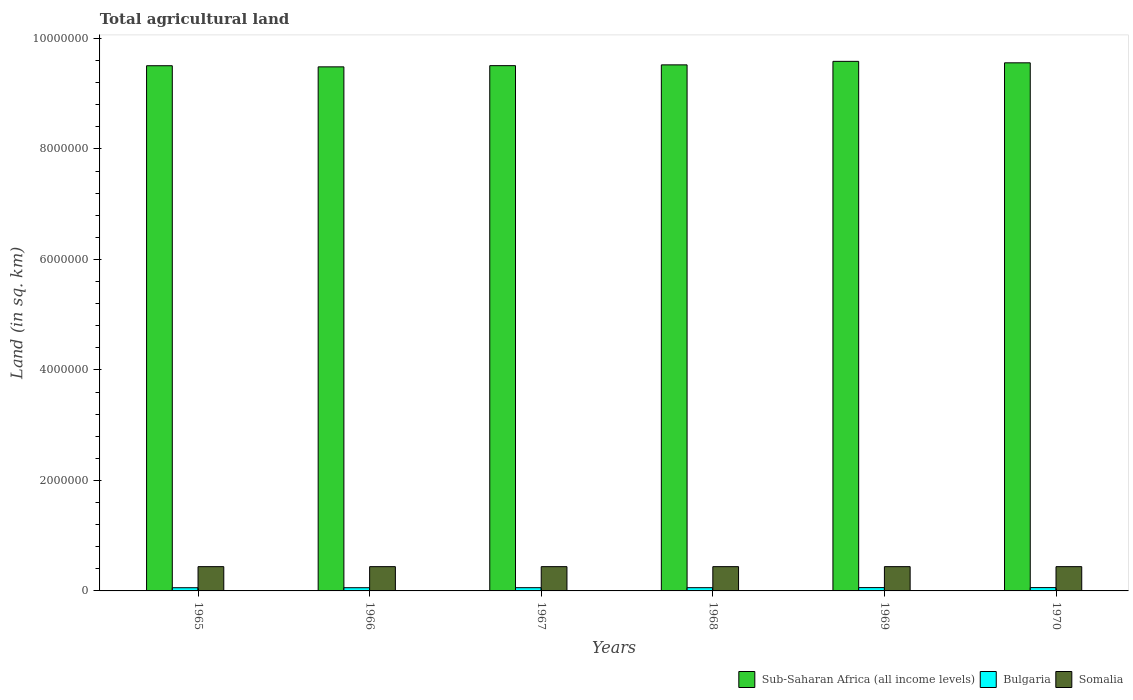How many groups of bars are there?
Give a very brief answer. 6. Are the number of bars per tick equal to the number of legend labels?
Offer a terse response. Yes. How many bars are there on the 3rd tick from the right?
Your answer should be very brief. 3. What is the label of the 5th group of bars from the left?
Offer a very short reply. 1969. In how many cases, is the number of bars for a given year not equal to the number of legend labels?
Provide a short and direct response. 0. What is the total agricultural land in Sub-Saharan Africa (all income levels) in 1970?
Offer a terse response. 9.56e+06. Across all years, what is the maximum total agricultural land in Sub-Saharan Africa (all income levels)?
Your response must be concise. 9.59e+06. Across all years, what is the minimum total agricultural land in Somalia?
Your response must be concise. 4.39e+05. In which year was the total agricultural land in Sub-Saharan Africa (all income levels) maximum?
Your response must be concise. 1969. In which year was the total agricultural land in Somalia minimum?
Your answer should be very brief. 1965. What is the total total agricultural land in Somalia in the graph?
Keep it short and to the point. 2.64e+06. What is the difference between the total agricultural land in Somalia in 1965 and that in 1970?
Keep it short and to the point. -250. What is the difference between the total agricultural land in Sub-Saharan Africa (all income levels) in 1968 and the total agricultural land in Somalia in 1967?
Your response must be concise. 9.08e+06. What is the average total agricultural land in Sub-Saharan Africa (all income levels) per year?
Offer a very short reply. 9.53e+06. In the year 1968, what is the difference between the total agricultural land in Somalia and total agricultural land in Sub-Saharan Africa (all income levels)?
Give a very brief answer. -9.08e+06. In how many years, is the total agricultural land in Bulgaria greater than 7200000 sq.km?
Your answer should be very brief. 0. What is the ratio of the total agricultural land in Bulgaria in 1965 to that in 1968?
Ensure brevity in your answer.  0.99. Is the difference between the total agricultural land in Somalia in 1966 and 1970 greater than the difference between the total agricultural land in Sub-Saharan Africa (all income levels) in 1966 and 1970?
Your response must be concise. Yes. What is the difference between the highest and the lowest total agricultural land in Bulgaria?
Make the answer very short. 2290. In how many years, is the total agricultural land in Bulgaria greater than the average total agricultural land in Bulgaria taken over all years?
Keep it short and to the point. 2. What does the 1st bar from the left in 1969 represents?
Your response must be concise. Sub-Saharan Africa (all income levels). What does the 3rd bar from the right in 1970 represents?
Offer a terse response. Sub-Saharan Africa (all income levels). How many bars are there?
Provide a succinct answer. 18. Are the values on the major ticks of Y-axis written in scientific E-notation?
Make the answer very short. No. Does the graph contain any zero values?
Give a very brief answer. No. Does the graph contain grids?
Provide a short and direct response. No. How many legend labels are there?
Offer a very short reply. 3. What is the title of the graph?
Provide a short and direct response. Total agricultural land. What is the label or title of the X-axis?
Offer a very short reply. Years. What is the label or title of the Y-axis?
Provide a succinct answer. Land (in sq. km). What is the Land (in sq. km) in Sub-Saharan Africa (all income levels) in 1965?
Your answer should be very brief. 9.51e+06. What is the Land (in sq. km) of Bulgaria in 1965?
Make the answer very short. 5.79e+04. What is the Land (in sq. km) of Somalia in 1965?
Ensure brevity in your answer.  4.39e+05. What is the Land (in sq. km) in Sub-Saharan Africa (all income levels) in 1966?
Keep it short and to the point. 9.49e+06. What is the Land (in sq. km) of Bulgaria in 1966?
Keep it short and to the point. 5.80e+04. What is the Land (in sq. km) in Somalia in 1966?
Offer a terse response. 4.39e+05. What is the Land (in sq. km) of Sub-Saharan Africa (all income levels) in 1967?
Provide a succinct answer. 9.51e+06. What is the Land (in sq. km) in Bulgaria in 1967?
Your answer should be very brief. 5.86e+04. What is the Land (in sq. km) in Somalia in 1967?
Give a very brief answer. 4.39e+05. What is the Land (in sq. km) in Sub-Saharan Africa (all income levels) in 1968?
Keep it short and to the point. 9.52e+06. What is the Land (in sq. km) of Bulgaria in 1968?
Ensure brevity in your answer.  5.88e+04. What is the Land (in sq. km) of Somalia in 1968?
Your answer should be compact. 4.39e+05. What is the Land (in sq. km) in Sub-Saharan Africa (all income levels) in 1969?
Offer a terse response. 9.59e+06. What is the Land (in sq. km) of Bulgaria in 1969?
Provide a short and direct response. 6.02e+04. What is the Land (in sq. km) in Somalia in 1969?
Give a very brief answer. 4.39e+05. What is the Land (in sq. km) in Sub-Saharan Africa (all income levels) in 1970?
Make the answer very short. 9.56e+06. What is the Land (in sq. km) in Bulgaria in 1970?
Your answer should be very brief. 6.01e+04. What is the Land (in sq. km) in Somalia in 1970?
Give a very brief answer. 4.40e+05. Across all years, what is the maximum Land (in sq. km) of Sub-Saharan Africa (all income levels)?
Make the answer very short. 9.59e+06. Across all years, what is the maximum Land (in sq. km) in Bulgaria?
Provide a short and direct response. 6.02e+04. Across all years, what is the maximum Land (in sq. km) of Somalia?
Keep it short and to the point. 4.40e+05. Across all years, what is the minimum Land (in sq. km) of Sub-Saharan Africa (all income levels)?
Your answer should be compact. 9.49e+06. Across all years, what is the minimum Land (in sq. km) of Bulgaria?
Offer a terse response. 5.79e+04. Across all years, what is the minimum Land (in sq. km) in Somalia?
Offer a terse response. 4.39e+05. What is the total Land (in sq. km) in Sub-Saharan Africa (all income levels) in the graph?
Your answer should be very brief. 5.72e+07. What is the total Land (in sq. km) of Bulgaria in the graph?
Ensure brevity in your answer.  3.54e+05. What is the total Land (in sq. km) in Somalia in the graph?
Your response must be concise. 2.64e+06. What is the difference between the Land (in sq. km) in Sub-Saharan Africa (all income levels) in 1965 and that in 1966?
Your answer should be compact. 2.05e+04. What is the difference between the Land (in sq. km) of Bulgaria in 1965 and that in 1966?
Offer a terse response. -90. What is the difference between the Land (in sq. km) in Somalia in 1965 and that in 1966?
Your answer should be compact. -50. What is the difference between the Land (in sq. km) in Sub-Saharan Africa (all income levels) in 1965 and that in 1967?
Your answer should be compact. -1287.4. What is the difference between the Land (in sq. km) in Bulgaria in 1965 and that in 1967?
Keep it short and to the point. -700. What is the difference between the Land (in sq. km) in Somalia in 1965 and that in 1967?
Provide a short and direct response. -100. What is the difference between the Land (in sq. km) of Sub-Saharan Africa (all income levels) in 1965 and that in 1968?
Give a very brief answer. -1.55e+04. What is the difference between the Land (in sq. km) of Bulgaria in 1965 and that in 1968?
Provide a succinct answer. -880. What is the difference between the Land (in sq. km) in Somalia in 1965 and that in 1968?
Make the answer very short. -150. What is the difference between the Land (in sq. km) of Sub-Saharan Africa (all income levels) in 1965 and that in 1969?
Offer a terse response. -7.91e+04. What is the difference between the Land (in sq. km) of Bulgaria in 1965 and that in 1969?
Provide a succinct answer. -2290. What is the difference between the Land (in sq. km) in Somalia in 1965 and that in 1969?
Ensure brevity in your answer.  -200. What is the difference between the Land (in sq. km) in Sub-Saharan Africa (all income levels) in 1965 and that in 1970?
Keep it short and to the point. -5.25e+04. What is the difference between the Land (in sq. km) in Bulgaria in 1965 and that in 1970?
Your answer should be very brief. -2170. What is the difference between the Land (in sq. km) of Somalia in 1965 and that in 1970?
Offer a terse response. -250. What is the difference between the Land (in sq. km) in Sub-Saharan Africa (all income levels) in 1966 and that in 1967?
Keep it short and to the point. -2.18e+04. What is the difference between the Land (in sq. km) in Bulgaria in 1966 and that in 1967?
Your answer should be very brief. -610. What is the difference between the Land (in sq. km) of Sub-Saharan Africa (all income levels) in 1966 and that in 1968?
Your answer should be compact. -3.60e+04. What is the difference between the Land (in sq. km) of Bulgaria in 1966 and that in 1968?
Offer a very short reply. -790. What is the difference between the Land (in sq. km) of Somalia in 1966 and that in 1968?
Keep it short and to the point. -100. What is the difference between the Land (in sq. km) of Sub-Saharan Africa (all income levels) in 1966 and that in 1969?
Your response must be concise. -9.96e+04. What is the difference between the Land (in sq. km) in Bulgaria in 1966 and that in 1969?
Keep it short and to the point. -2200. What is the difference between the Land (in sq. km) in Somalia in 1966 and that in 1969?
Offer a terse response. -150. What is the difference between the Land (in sq. km) in Sub-Saharan Africa (all income levels) in 1966 and that in 1970?
Provide a short and direct response. -7.30e+04. What is the difference between the Land (in sq. km) in Bulgaria in 1966 and that in 1970?
Provide a succinct answer. -2080. What is the difference between the Land (in sq. km) of Somalia in 1966 and that in 1970?
Provide a short and direct response. -200. What is the difference between the Land (in sq. km) of Sub-Saharan Africa (all income levels) in 1967 and that in 1968?
Provide a succinct answer. -1.42e+04. What is the difference between the Land (in sq. km) of Bulgaria in 1967 and that in 1968?
Keep it short and to the point. -180. What is the difference between the Land (in sq. km) of Somalia in 1967 and that in 1968?
Your answer should be very brief. -50. What is the difference between the Land (in sq. km) in Sub-Saharan Africa (all income levels) in 1967 and that in 1969?
Keep it short and to the point. -7.78e+04. What is the difference between the Land (in sq. km) of Bulgaria in 1967 and that in 1969?
Make the answer very short. -1590. What is the difference between the Land (in sq. km) of Somalia in 1967 and that in 1969?
Make the answer very short. -100. What is the difference between the Land (in sq. km) of Sub-Saharan Africa (all income levels) in 1967 and that in 1970?
Give a very brief answer. -5.13e+04. What is the difference between the Land (in sq. km) in Bulgaria in 1967 and that in 1970?
Offer a very short reply. -1470. What is the difference between the Land (in sq. km) of Somalia in 1967 and that in 1970?
Provide a succinct answer. -150. What is the difference between the Land (in sq. km) in Sub-Saharan Africa (all income levels) in 1968 and that in 1969?
Your answer should be compact. -6.36e+04. What is the difference between the Land (in sq. km) of Bulgaria in 1968 and that in 1969?
Ensure brevity in your answer.  -1410. What is the difference between the Land (in sq. km) in Somalia in 1968 and that in 1969?
Offer a terse response. -50. What is the difference between the Land (in sq. km) of Sub-Saharan Africa (all income levels) in 1968 and that in 1970?
Provide a short and direct response. -3.71e+04. What is the difference between the Land (in sq. km) of Bulgaria in 1968 and that in 1970?
Your answer should be compact. -1290. What is the difference between the Land (in sq. km) in Somalia in 1968 and that in 1970?
Provide a succinct answer. -100. What is the difference between the Land (in sq. km) of Sub-Saharan Africa (all income levels) in 1969 and that in 1970?
Your answer should be compact. 2.66e+04. What is the difference between the Land (in sq. km) in Bulgaria in 1969 and that in 1970?
Make the answer very short. 120. What is the difference between the Land (in sq. km) of Sub-Saharan Africa (all income levels) in 1965 and the Land (in sq. km) of Bulgaria in 1966?
Your answer should be very brief. 9.45e+06. What is the difference between the Land (in sq. km) in Sub-Saharan Africa (all income levels) in 1965 and the Land (in sq. km) in Somalia in 1966?
Make the answer very short. 9.07e+06. What is the difference between the Land (in sq. km) in Bulgaria in 1965 and the Land (in sq. km) in Somalia in 1966?
Provide a short and direct response. -3.81e+05. What is the difference between the Land (in sq. km) of Sub-Saharan Africa (all income levels) in 1965 and the Land (in sq. km) of Bulgaria in 1967?
Your response must be concise. 9.45e+06. What is the difference between the Land (in sq. km) in Sub-Saharan Africa (all income levels) in 1965 and the Land (in sq. km) in Somalia in 1967?
Provide a short and direct response. 9.07e+06. What is the difference between the Land (in sq. km) of Bulgaria in 1965 and the Land (in sq. km) of Somalia in 1967?
Make the answer very short. -3.81e+05. What is the difference between the Land (in sq. km) in Sub-Saharan Africa (all income levels) in 1965 and the Land (in sq. km) in Bulgaria in 1968?
Ensure brevity in your answer.  9.45e+06. What is the difference between the Land (in sq. km) in Sub-Saharan Africa (all income levels) in 1965 and the Land (in sq. km) in Somalia in 1968?
Your answer should be very brief. 9.07e+06. What is the difference between the Land (in sq. km) in Bulgaria in 1965 and the Land (in sq. km) in Somalia in 1968?
Offer a terse response. -3.81e+05. What is the difference between the Land (in sq. km) in Sub-Saharan Africa (all income levels) in 1965 and the Land (in sq. km) in Bulgaria in 1969?
Provide a short and direct response. 9.45e+06. What is the difference between the Land (in sq. km) of Sub-Saharan Africa (all income levels) in 1965 and the Land (in sq. km) of Somalia in 1969?
Provide a succinct answer. 9.07e+06. What is the difference between the Land (in sq. km) of Bulgaria in 1965 and the Land (in sq. km) of Somalia in 1969?
Ensure brevity in your answer.  -3.82e+05. What is the difference between the Land (in sq. km) in Sub-Saharan Africa (all income levels) in 1965 and the Land (in sq. km) in Bulgaria in 1970?
Your answer should be compact. 9.45e+06. What is the difference between the Land (in sq. km) of Sub-Saharan Africa (all income levels) in 1965 and the Land (in sq. km) of Somalia in 1970?
Offer a very short reply. 9.07e+06. What is the difference between the Land (in sq. km) of Bulgaria in 1965 and the Land (in sq. km) of Somalia in 1970?
Offer a very short reply. -3.82e+05. What is the difference between the Land (in sq. km) of Sub-Saharan Africa (all income levels) in 1966 and the Land (in sq. km) of Bulgaria in 1967?
Your answer should be very brief. 9.43e+06. What is the difference between the Land (in sq. km) in Sub-Saharan Africa (all income levels) in 1966 and the Land (in sq. km) in Somalia in 1967?
Offer a terse response. 9.05e+06. What is the difference between the Land (in sq. km) of Bulgaria in 1966 and the Land (in sq. km) of Somalia in 1967?
Make the answer very short. -3.81e+05. What is the difference between the Land (in sq. km) of Sub-Saharan Africa (all income levels) in 1966 and the Land (in sq. km) of Bulgaria in 1968?
Provide a short and direct response. 9.43e+06. What is the difference between the Land (in sq. km) in Sub-Saharan Africa (all income levels) in 1966 and the Land (in sq. km) in Somalia in 1968?
Provide a succinct answer. 9.05e+06. What is the difference between the Land (in sq. km) in Bulgaria in 1966 and the Land (in sq. km) in Somalia in 1968?
Make the answer very short. -3.81e+05. What is the difference between the Land (in sq. km) in Sub-Saharan Africa (all income levels) in 1966 and the Land (in sq. km) in Bulgaria in 1969?
Your answer should be very brief. 9.43e+06. What is the difference between the Land (in sq. km) in Sub-Saharan Africa (all income levels) in 1966 and the Land (in sq. km) in Somalia in 1969?
Offer a very short reply. 9.05e+06. What is the difference between the Land (in sq. km) of Bulgaria in 1966 and the Land (in sq. km) of Somalia in 1969?
Provide a succinct answer. -3.81e+05. What is the difference between the Land (in sq. km) in Sub-Saharan Africa (all income levels) in 1966 and the Land (in sq. km) in Bulgaria in 1970?
Ensure brevity in your answer.  9.43e+06. What is the difference between the Land (in sq. km) of Sub-Saharan Africa (all income levels) in 1966 and the Land (in sq. km) of Somalia in 1970?
Your answer should be compact. 9.05e+06. What is the difference between the Land (in sq. km) of Bulgaria in 1966 and the Land (in sq. km) of Somalia in 1970?
Make the answer very short. -3.81e+05. What is the difference between the Land (in sq. km) in Sub-Saharan Africa (all income levels) in 1967 and the Land (in sq. km) in Bulgaria in 1968?
Give a very brief answer. 9.45e+06. What is the difference between the Land (in sq. km) of Sub-Saharan Africa (all income levels) in 1967 and the Land (in sq. km) of Somalia in 1968?
Make the answer very short. 9.07e+06. What is the difference between the Land (in sq. km) in Bulgaria in 1967 and the Land (in sq. km) in Somalia in 1968?
Keep it short and to the point. -3.81e+05. What is the difference between the Land (in sq. km) in Sub-Saharan Africa (all income levels) in 1967 and the Land (in sq. km) in Bulgaria in 1969?
Make the answer very short. 9.45e+06. What is the difference between the Land (in sq. km) of Sub-Saharan Africa (all income levels) in 1967 and the Land (in sq. km) of Somalia in 1969?
Offer a terse response. 9.07e+06. What is the difference between the Land (in sq. km) in Bulgaria in 1967 and the Land (in sq. km) in Somalia in 1969?
Your answer should be compact. -3.81e+05. What is the difference between the Land (in sq. km) in Sub-Saharan Africa (all income levels) in 1967 and the Land (in sq. km) in Bulgaria in 1970?
Keep it short and to the point. 9.45e+06. What is the difference between the Land (in sq. km) of Sub-Saharan Africa (all income levels) in 1967 and the Land (in sq. km) of Somalia in 1970?
Keep it short and to the point. 9.07e+06. What is the difference between the Land (in sq. km) of Bulgaria in 1967 and the Land (in sq. km) of Somalia in 1970?
Offer a very short reply. -3.81e+05. What is the difference between the Land (in sq. km) of Sub-Saharan Africa (all income levels) in 1968 and the Land (in sq. km) of Bulgaria in 1969?
Keep it short and to the point. 9.46e+06. What is the difference between the Land (in sq. km) in Sub-Saharan Africa (all income levels) in 1968 and the Land (in sq. km) in Somalia in 1969?
Provide a short and direct response. 9.08e+06. What is the difference between the Land (in sq. km) of Bulgaria in 1968 and the Land (in sq. km) of Somalia in 1969?
Your answer should be very brief. -3.81e+05. What is the difference between the Land (in sq. km) of Sub-Saharan Africa (all income levels) in 1968 and the Land (in sq. km) of Bulgaria in 1970?
Make the answer very short. 9.46e+06. What is the difference between the Land (in sq. km) of Sub-Saharan Africa (all income levels) in 1968 and the Land (in sq. km) of Somalia in 1970?
Keep it short and to the point. 9.08e+06. What is the difference between the Land (in sq. km) in Bulgaria in 1968 and the Land (in sq. km) in Somalia in 1970?
Your answer should be compact. -3.81e+05. What is the difference between the Land (in sq. km) in Sub-Saharan Africa (all income levels) in 1969 and the Land (in sq. km) in Bulgaria in 1970?
Offer a very short reply. 9.53e+06. What is the difference between the Land (in sq. km) of Sub-Saharan Africa (all income levels) in 1969 and the Land (in sq. km) of Somalia in 1970?
Keep it short and to the point. 9.15e+06. What is the difference between the Land (in sq. km) of Bulgaria in 1969 and the Land (in sq. km) of Somalia in 1970?
Ensure brevity in your answer.  -3.79e+05. What is the average Land (in sq. km) in Sub-Saharan Africa (all income levels) per year?
Your answer should be compact. 9.53e+06. What is the average Land (in sq. km) in Bulgaria per year?
Ensure brevity in your answer.  5.90e+04. What is the average Land (in sq. km) in Somalia per year?
Your answer should be compact. 4.39e+05. In the year 1965, what is the difference between the Land (in sq. km) of Sub-Saharan Africa (all income levels) and Land (in sq. km) of Bulgaria?
Provide a succinct answer. 9.45e+06. In the year 1965, what is the difference between the Land (in sq. km) of Sub-Saharan Africa (all income levels) and Land (in sq. km) of Somalia?
Provide a short and direct response. 9.07e+06. In the year 1965, what is the difference between the Land (in sq. km) of Bulgaria and Land (in sq. km) of Somalia?
Give a very brief answer. -3.81e+05. In the year 1966, what is the difference between the Land (in sq. km) of Sub-Saharan Africa (all income levels) and Land (in sq. km) of Bulgaria?
Make the answer very short. 9.43e+06. In the year 1966, what is the difference between the Land (in sq. km) of Sub-Saharan Africa (all income levels) and Land (in sq. km) of Somalia?
Your answer should be compact. 9.05e+06. In the year 1966, what is the difference between the Land (in sq. km) in Bulgaria and Land (in sq. km) in Somalia?
Your response must be concise. -3.81e+05. In the year 1967, what is the difference between the Land (in sq. km) of Sub-Saharan Africa (all income levels) and Land (in sq. km) of Bulgaria?
Provide a succinct answer. 9.45e+06. In the year 1967, what is the difference between the Land (in sq. km) in Sub-Saharan Africa (all income levels) and Land (in sq. km) in Somalia?
Provide a short and direct response. 9.07e+06. In the year 1967, what is the difference between the Land (in sq. km) of Bulgaria and Land (in sq. km) of Somalia?
Give a very brief answer. -3.81e+05. In the year 1968, what is the difference between the Land (in sq. km) of Sub-Saharan Africa (all income levels) and Land (in sq. km) of Bulgaria?
Your response must be concise. 9.46e+06. In the year 1968, what is the difference between the Land (in sq. km) of Sub-Saharan Africa (all income levels) and Land (in sq. km) of Somalia?
Your answer should be very brief. 9.08e+06. In the year 1968, what is the difference between the Land (in sq. km) in Bulgaria and Land (in sq. km) in Somalia?
Offer a terse response. -3.81e+05. In the year 1969, what is the difference between the Land (in sq. km) of Sub-Saharan Africa (all income levels) and Land (in sq. km) of Bulgaria?
Your response must be concise. 9.53e+06. In the year 1969, what is the difference between the Land (in sq. km) in Sub-Saharan Africa (all income levels) and Land (in sq. km) in Somalia?
Give a very brief answer. 9.15e+06. In the year 1969, what is the difference between the Land (in sq. km) of Bulgaria and Land (in sq. km) of Somalia?
Offer a terse response. -3.79e+05. In the year 1970, what is the difference between the Land (in sq. km) in Sub-Saharan Africa (all income levels) and Land (in sq. km) in Bulgaria?
Provide a short and direct response. 9.50e+06. In the year 1970, what is the difference between the Land (in sq. km) in Sub-Saharan Africa (all income levels) and Land (in sq. km) in Somalia?
Give a very brief answer. 9.12e+06. In the year 1970, what is the difference between the Land (in sq. km) in Bulgaria and Land (in sq. km) in Somalia?
Make the answer very short. -3.79e+05. What is the ratio of the Land (in sq. km) of Sub-Saharan Africa (all income levels) in 1965 to that in 1966?
Give a very brief answer. 1. What is the ratio of the Land (in sq. km) of Bulgaria in 1965 to that in 1966?
Your response must be concise. 1. What is the ratio of the Land (in sq. km) of Somalia in 1965 to that in 1966?
Make the answer very short. 1. What is the ratio of the Land (in sq. km) of Sub-Saharan Africa (all income levels) in 1965 to that in 1967?
Ensure brevity in your answer.  1. What is the ratio of the Land (in sq. km) in Bulgaria in 1965 to that in 1968?
Ensure brevity in your answer.  0.98. What is the ratio of the Land (in sq. km) of Bulgaria in 1965 to that in 1969?
Offer a very short reply. 0.96. What is the ratio of the Land (in sq. km) of Somalia in 1965 to that in 1969?
Offer a very short reply. 1. What is the ratio of the Land (in sq. km) of Sub-Saharan Africa (all income levels) in 1965 to that in 1970?
Your answer should be compact. 0.99. What is the ratio of the Land (in sq. km) of Bulgaria in 1965 to that in 1970?
Provide a succinct answer. 0.96. What is the ratio of the Land (in sq. km) of Somalia in 1965 to that in 1970?
Give a very brief answer. 1. What is the ratio of the Land (in sq. km) in Sub-Saharan Africa (all income levels) in 1966 to that in 1967?
Make the answer very short. 1. What is the ratio of the Land (in sq. km) of Sub-Saharan Africa (all income levels) in 1966 to that in 1968?
Offer a very short reply. 1. What is the ratio of the Land (in sq. km) of Bulgaria in 1966 to that in 1968?
Give a very brief answer. 0.99. What is the ratio of the Land (in sq. km) in Bulgaria in 1966 to that in 1969?
Your answer should be very brief. 0.96. What is the ratio of the Land (in sq. km) in Somalia in 1966 to that in 1969?
Your answer should be very brief. 1. What is the ratio of the Land (in sq. km) of Sub-Saharan Africa (all income levels) in 1966 to that in 1970?
Provide a short and direct response. 0.99. What is the ratio of the Land (in sq. km) of Bulgaria in 1966 to that in 1970?
Provide a succinct answer. 0.97. What is the ratio of the Land (in sq. km) in Somalia in 1966 to that in 1970?
Provide a short and direct response. 1. What is the ratio of the Land (in sq. km) in Sub-Saharan Africa (all income levels) in 1967 to that in 1968?
Your answer should be compact. 1. What is the ratio of the Land (in sq. km) of Sub-Saharan Africa (all income levels) in 1967 to that in 1969?
Provide a short and direct response. 0.99. What is the ratio of the Land (in sq. km) of Bulgaria in 1967 to that in 1969?
Provide a succinct answer. 0.97. What is the ratio of the Land (in sq. km) in Somalia in 1967 to that in 1969?
Make the answer very short. 1. What is the ratio of the Land (in sq. km) of Sub-Saharan Africa (all income levels) in 1967 to that in 1970?
Offer a terse response. 0.99. What is the ratio of the Land (in sq. km) of Bulgaria in 1967 to that in 1970?
Keep it short and to the point. 0.98. What is the ratio of the Land (in sq. km) in Somalia in 1967 to that in 1970?
Make the answer very short. 1. What is the ratio of the Land (in sq. km) in Bulgaria in 1968 to that in 1969?
Offer a terse response. 0.98. What is the ratio of the Land (in sq. km) of Somalia in 1968 to that in 1969?
Make the answer very short. 1. What is the ratio of the Land (in sq. km) of Bulgaria in 1968 to that in 1970?
Provide a short and direct response. 0.98. What is the ratio of the Land (in sq. km) of Bulgaria in 1969 to that in 1970?
Provide a short and direct response. 1. What is the ratio of the Land (in sq. km) in Somalia in 1969 to that in 1970?
Provide a short and direct response. 1. What is the difference between the highest and the second highest Land (in sq. km) of Sub-Saharan Africa (all income levels)?
Your answer should be very brief. 2.66e+04. What is the difference between the highest and the second highest Land (in sq. km) in Bulgaria?
Your answer should be compact. 120. What is the difference between the highest and the lowest Land (in sq. km) in Sub-Saharan Africa (all income levels)?
Make the answer very short. 9.96e+04. What is the difference between the highest and the lowest Land (in sq. km) of Bulgaria?
Offer a terse response. 2290. What is the difference between the highest and the lowest Land (in sq. km) in Somalia?
Your response must be concise. 250. 